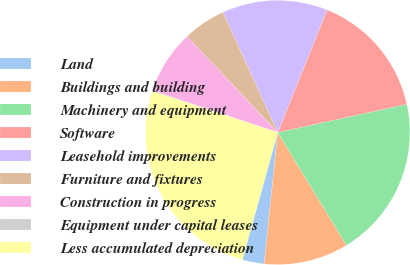<chart> <loc_0><loc_0><loc_500><loc_500><pie_chart><fcel>Land<fcel>Buildings and building<fcel>Machinery and equipment<fcel>Software<fcel>Leasehold improvements<fcel>Furniture and fixtures<fcel>Construction in progress<fcel>Equipment under capital leases<fcel>Less accumulated depreciation<nl><fcel>2.68%<fcel>10.35%<fcel>19.72%<fcel>15.47%<fcel>12.91%<fcel>5.24%<fcel>7.8%<fcel>0.12%<fcel>25.71%<nl></chart> 